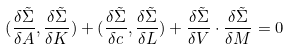Convert formula to latex. <formula><loc_0><loc_0><loc_500><loc_500>( \frac { \delta \tilde { \Sigma } } { \delta A } , \frac { \delta \tilde { \Sigma } } { \delta K } ) + ( \frac { \delta \tilde { \Sigma } } { \delta c } , \frac { \delta \tilde { \Sigma } } { \delta L } ) + \frac { \delta \tilde { \Sigma } } { \delta V } \cdot \frac { \delta \tilde { \Sigma } } { \delta M } = 0</formula> 